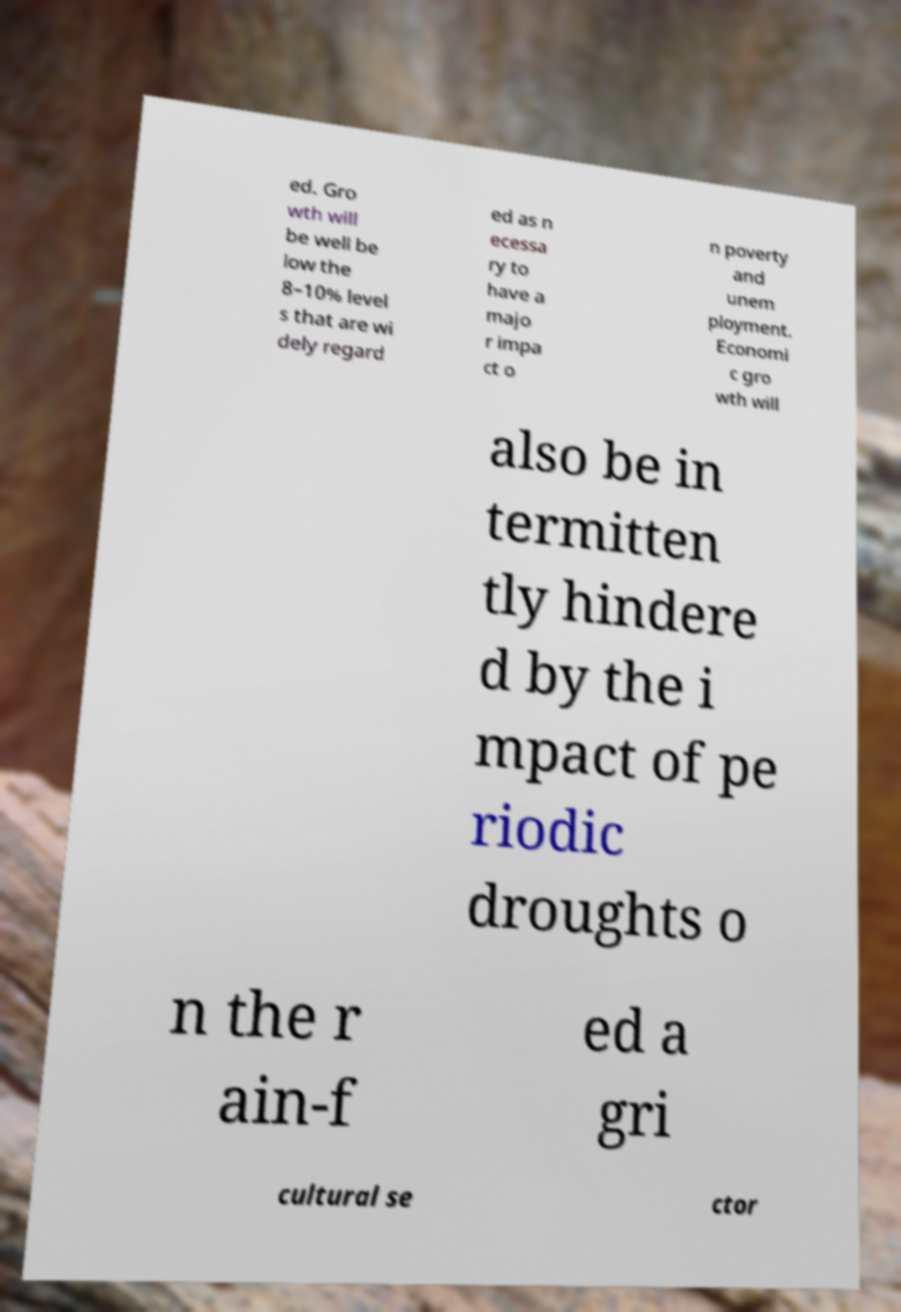I need the written content from this picture converted into text. Can you do that? ed. Gro wth will be well be low the 8–10% level s that are wi dely regard ed as n ecessa ry to have a majo r impa ct o n poverty and unem ployment. Economi c gro wth will also be in termitten tly hindere d by the i mpact of pe riodic droughts o n the r ain-f ed a gri cultural se ctor 